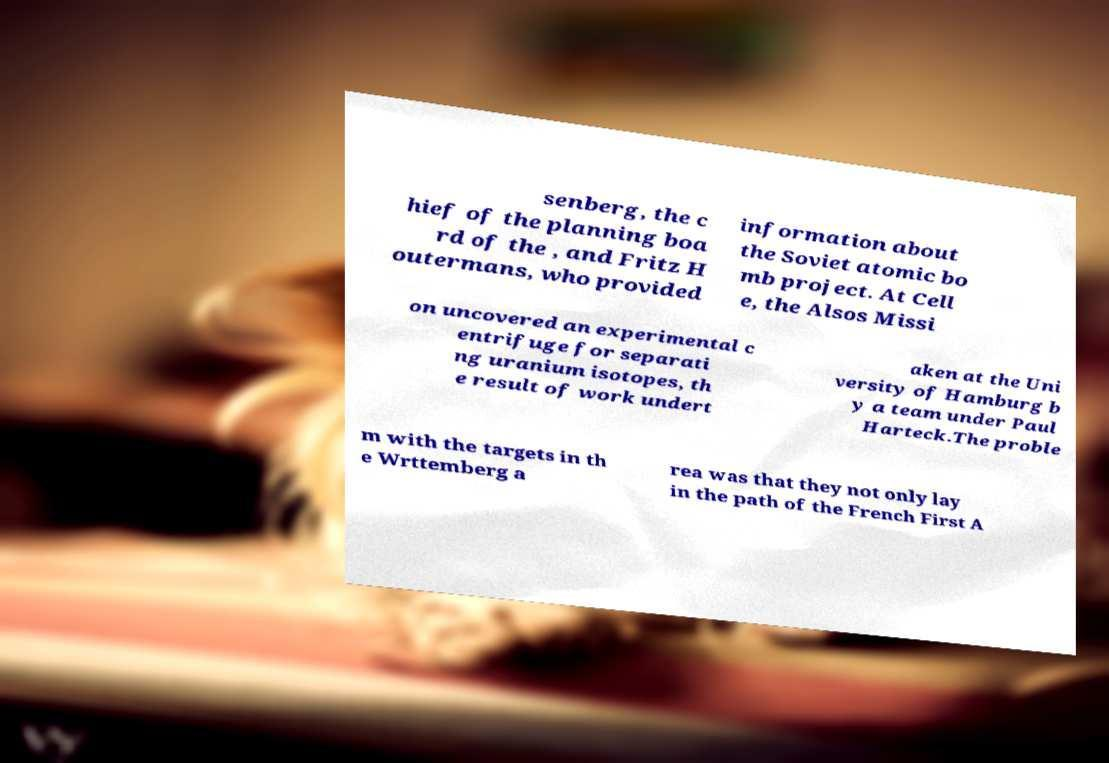I need the written content from this picture converted into text. Can you do that? senberg, the c hief of the planning boa rd of the , and Fritz H outermans, who provided information about the Soviet atomic bo mb project. At Cell e, the Alsos Missi on uncovered an experimental c entrifuge for separati ng uranium isotopes, th e result of work undert aken at the Uni versity of Hamburg b y a team under Paul Harteck.The proble m with the targets in th e Wrttemberg a rea was that they not only lay in the path of the French First A 